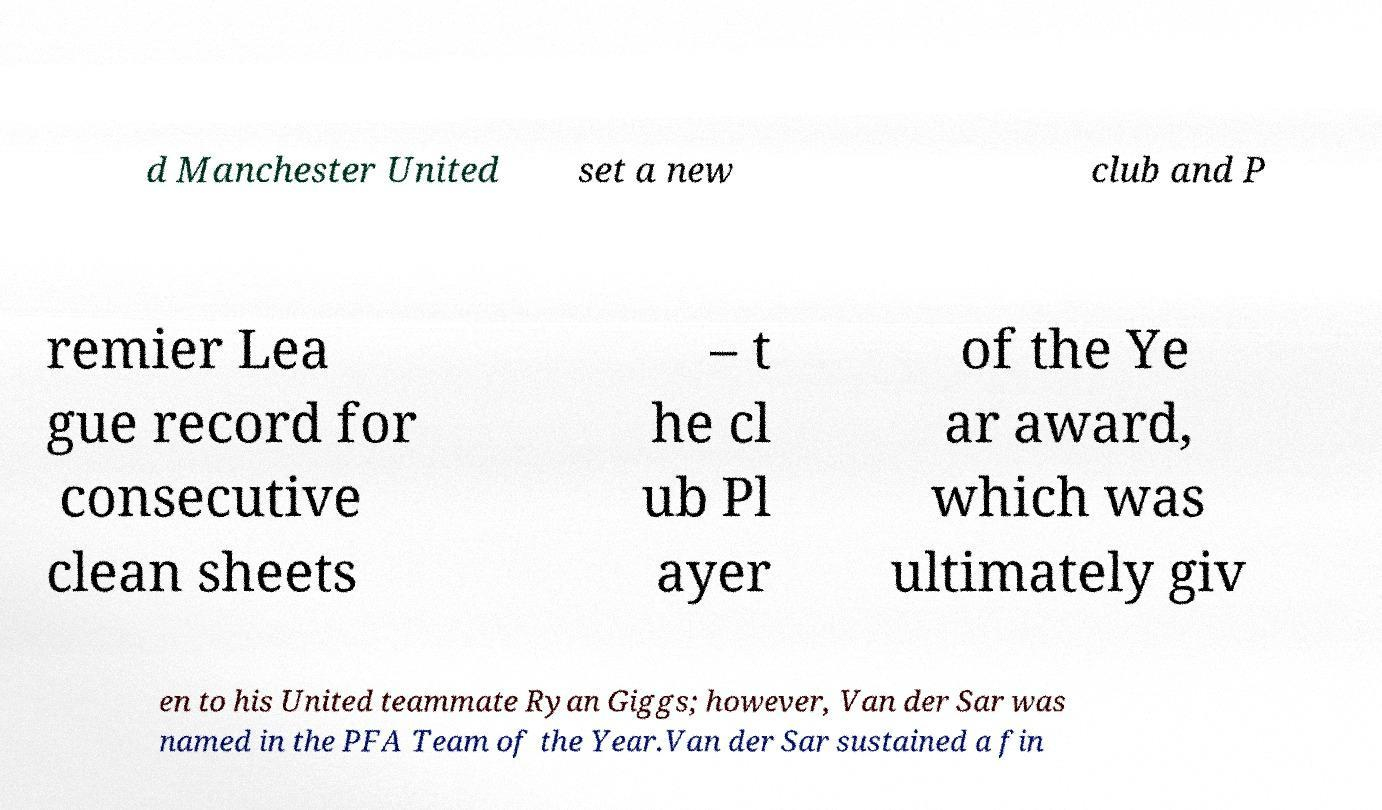What messages or text are displayed in this image? I need them in a readable, typed format. d Manchester United set a new club and P remier Lea gue record for consecutive clean sheets – t he cl ub Pl ayer of the Ye ar award, which was ultimately giv en to his United teammate Ryan Giggs; however, Van der Sar was named in the PFA Team of the Year.Van der Sar sustained a fin 